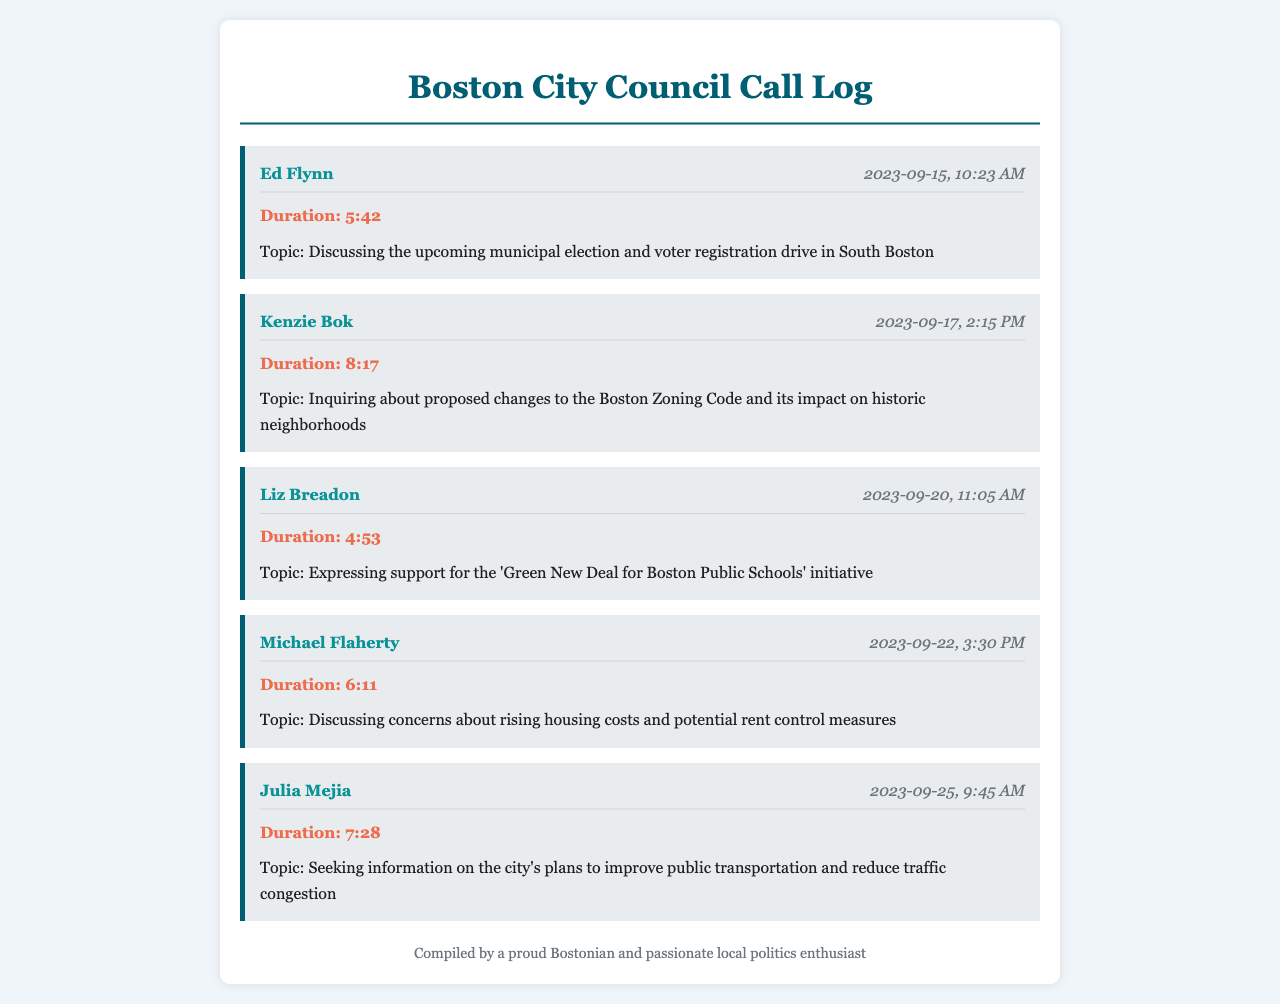What is the date of the call with Ed Flynn? The date is provided directly in the call log entry for Ed Flynn's call, which is 2023-09-15.
Answer: 2023-09-15 How long was the call with Kenzie Bok? The duration of the call with Kenzie Bok is explicitly stated in the entry, which is 8:17.
Answer: 8:17 What topic was discussed during Liz Breadon's call? The topic discussed during Liz Breadon's call is listed in her entry, mentioning support for an initiative.
Answer: 'Green New Deal for Boston Public Schools' initiative Which council member was called on September 22? The call log provides the name of the council member called on that date, Michael Flaherty.
Answer: Michael Flaherty What concerns were raised in the call with Michael Flaherty? The concerns are directly listed in the call entry for Michael Flaherty, referring to housing costs and rent control.
Answer: Rising housing costs and potential rent control measures Which member discussed transportation issues? The document states that Julia Mejia sought information on public transportation during her call.
Answer: Julia Mejia How many calls were made to council members in total? The total number of call entries provided in the document indicates how many calls were logged.
Answer: 5 What is the common theme of the calls? The calls primarily focus on local political issues and proposals related to the upcoming municipal election.
Answer: Local political issues Who had the shortest call duration? The duration is noted for each call; Liz Breadon's call had the shortest duration listed.
Answer: 4:53 